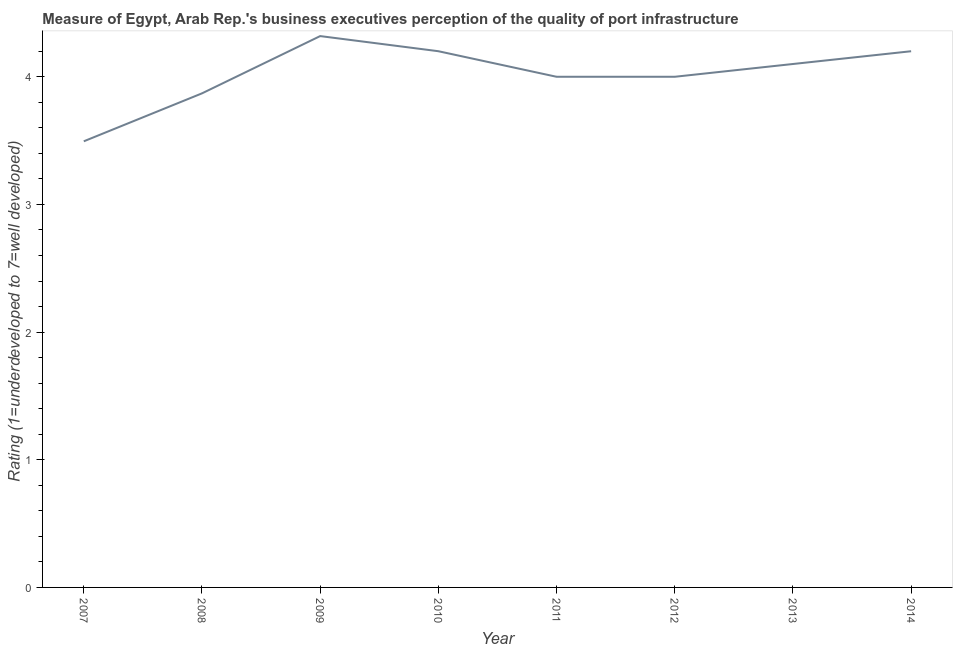What is the rating measuring quality of port infrastructure in 2010?
Offer a terse response. 4.2. Across all years, what is the maximum rating measuring quality of port infrastructure?
Make the answer very short. 4.32. Across all years, what is the minimum rating measuring quality of port infrastructure?
Ensure brevity in your answer.  3.49. In which year was the rating measuring quality of port infrastructure maximum?
Your answer should be very brief. 2009. What is the sum of the rating measuring quality of port infrastructure?
Ensure brevity in your answer.  32.18. What is the difference between the rating measuring quality of port infrastructure in 2009 and 2014?
Your response must be concise. 0.12. What is the average rating measuring quality of port infrastructure per year?
Make the answer very short. 4.02. What is the median rating measuring quality of port infrastructure?
Provide a short and direct response. 4.05. In how many years, is the rating measuring quality of port infrastructure greater than 0.2 ?
Give a very brief answer. 8. Do a majority of the years between 2010 and 2014 (inclusive) have rating measuring quality of port infrastructure greater than 3.8 ?
Offer a very short reply. Yes. What is the ratio of the rating measuring quality of port infrastructure in 2011 to that in 2013?
Provide a short and direct response. 0.98. Is the rating measuring quality of port infrastructure in 2007 less than that in 2014?
Give a very brief answer. Yes. Is the difference between the rating measuring quality of port infrastructure in 2008 and 2013 greater than the difference between any two years?
Provide a short and direct response. No. What is the difference between the highest and the second highest rating measuring quality of port infrastructure?
Offer a terse response. 0.12. Is the sum of the rating measuring quality of port infrastructure in 2013 and 2014 greater than the maximum rating measuring quality of port infrastructure across all years?
Provide a succinct answer. Yes. What is the difference between the highest and the lowest rating measuring quality of port infrastructure?
Provide a short and direct response. 0.82. How many lines are there?
Offer a terse response. 1. How many years are there in the graph?
Offer a very short reply. 8. Are the values on the major ticks of Y-axis written in scientific E-notation?
Your response must be concise. No. What is the title of the graph?
Offer a very short reply. Measure of Egypt, Arab Rep.'s business executives perception of the quality of port infrastructure. What is the label or title of the X-axis?
Provide a short and direct response. Year. What is the label or title of the Y-axis?
Give a very brief answer. Rating (1=underdeveloped to 7=well developed) . What is the Rating (1=underdeveloped to 7=well developed)  in 2007?
Your response must be concise. 3.49. What is the Rating (1=underdeveloped to 7=well developed)  of 2008?
Ensure brevity in your answer.  3.87. What is the Rating (1=underdeveloped to 7=well developed)  in 2009?
Provide a short and direct response. 4.32. What is the Rating (1=underdeveloped to 7=well developed)  in 2010?
Provide a succinct answer. 4.2. What is the Rating (1=underdeveloped to 7=well developed)  of 2011?
Ensure brevity in your answer.  4. What is the Rating (1=underdeveloped to 7=well developed)  in 2012?
Provide a short and direct response. 4. What is the difference between the Rating (1=underdeveloped to 7=well developed)  in 2007 and 2008?
Keep it short and to the point. -0.38. What is the difference between the Rating (1=underdeveloped to 7=well developed)  in 2007 and 2009?
Give a very brief answer. -0.82. What is the difference between the Rating (1=underdeveloped to 7=well developed)  in 2007 and 2010?
Keep it short and to the point. -0.71. What is the difference between the Rating (1=underdeveloped to 7=well developed)  in 2007 and 2011?
Offer a terse response. -0.51. What is the difference between the Rating (1=underdeveloped to 7=well developed)  in 2007 and 2012?
Offer a terse response. -0.51. What is the difference between the Rating (1=underdeveloped to 7=well developed)  in 2007 and 2013?
Your answer should be very brief. -0.61. What is the difference between the Rating (1=underdeveloped to 7=well developed)  in 2007 and 2014?
Offer a terse response. -0.71. What is the difference between the Rating (1=underdeveloped to 7=well developed)  in 2008 and 2009?
Your answer should be very brief. -0.45. What is the difference between the Rating (1=underdeveloped to 7=well developed)  in 2008 and 2010?
Give a very brief answer. -0.33. What is the difference between the Rating (1=underdeveloped to 7=well developed)  in 2008 and 2011?
Ensure brevity in your answer.  -0.13. What is the difference between the Rating (1=underdeveloped to 7=well developed)  in 2008 and 2012?
Keep it short and to the point. -0.13. What is the difference between the Rating (1=underdeveloped to 7=well developed)  in 2008 and 2013?
Provide a succinct answer. -0.23. What is the difference between the Rating (1=underdeveloped to 7=well developed)  in 2008 and 2014?
Your response must be concise. -0.33. What is the difference between the Rating (1=underdeveloped to 7=well developed)  in 2009 and 2010?
Your answer should be compact. 0.12. What is the difference between the Rating (1=underdeveloped to 7=well developed)  in 2009 and 2011?
Keep it short and to the point. 0.32. What is the difference between the Rating (1=underdeveloped to 7=well developed)  in 2009 and 2012?
Provide a short and direct response. 0.32. What is the difference between the Rating (1=underdeveloped to 7=well developed)  in 2009 and 2013?
Give a very brief answer. 0.22. What is the difference between the Rating (1=underdeveloped to 7=well developed)  in 2009 and 2014?
Give a very brief answer. 0.12. What is the difference between the Rating (1=underdeveloped to 7=well developed)  in 2010 and 2011?
Provide a short and direct response. 0.2. What is the difference between the Rating (1=underdeveloped to 7=well developed)  in 2010 and 2012?
Offer a very short reply. 0.2. What is the difference between the Rating (1=underdeveloped to 7=well developed)  in 2010 and 2013?
Your answer should be compact. 0.1. What is the difference between the Rating (1=underdeveloped to 7=well developed)  in 2010 and 2014?
Offer a very short reply. 0. What is the difference between the Rating (1=underdeveloped to 7=well developed)  in 2011 and 2013?
Offer a terse response. -0.1. What is the difference between the Rating (1=underdeveloped to 7=well developed)  in 2011 and 2014?
Offer a terse response. -0.2. What is the difference between the Rating (1=underdeveloped to 7=well developed)  in 2012 and 2013?
Offer a very short reply. -0.1. What is the difference between the Rating (1=underdeveloped to 7=well developed)  in 2012 and 2014?
Offer a very short reply. -0.2. What is the difference between the Rating (1=underdeveloped to 7=well developed)  in 2013 and 2014?
Keep it short and to the point. -0.1. What is the ratio of the Rating (1=underdeveloped to 7=well developed)  in 2007 to that in 2008?
Your response must be concise. 0.9. What is the ratio of the Rating (1=underdeveloped to 7=well developed)  in 2007 to that in 2009?
Offer a terse response. 0.81. What is the ratio of the Rating (1=underdeveloped to 7=well developed)  in 2007 to that in 2010?
Offer a terse response. 0.83. What is the ratio of the Rating (1=underdeveloped to 7=well developed)  in 2007 to that in 2011?
Make the answer very short. 0.87. What is the ratio of the Rating (1=underdeveloped to 7=well developed)  in 2007 to that in 2012?
Offer a terse response. 0.87. What is the ratio of the Rating (1=underdeveloped to 7=well developed)  in 2007 to that in 2013?
Provide a short and direct response. 0.85. What is the ratio of the Rating (1=underdeveloped to 7=well developed)  in 2007 to that in 2014?
Provide a short and direct response. 0.83. What is the ratio of the Rating (1=underdeveloped to 7=well developed)  in 2008 to that in 2009?
Give a very brief answer. 0.9. What is the ratio of the Rating (1=underdeveloped to 7=well developed)  in 2008 to that in 2010?
Your answer should be very brief. 0.92. What is the ratio of the Rating (1=underdeveloped to 7=well developed)  in 2008 to that in 2011?
Your answer should be very brief. 0.97. What is the ratio of the Rating (1=underdeveloped to 7=well developed)  in 2008 to that in 2013?
Your answer should be very brief. 0.94. What is the ratio of the Rating (1=underdeveloped to 7=well developed)  in 2008 to that in 2014?
Give a very brief answer. 0.92. What is the ratio of the Rating (1=underdeveloped to 7=well developed)  in 2009 to that in 2010?
Ensure brevity in your answer.  1.03. What is the ratio of the Rating (1=underdeveloped to 7=well developed)  in 2009 to that in 2011?
Your answer should be compact. 1.08. What is the ratio of the Rating (1=underdeveloped to 7=well developed)  in 2009 to that in 2013?
Your answer should be very brief. 1.05. What is the ratio of the Rating (1=underdeveloped to 7=well developed)  in 2009 to that in 2014?
Keep it short and to the point. 1.03. What is the ratio of the Rating (1=underdeveloped to 7=well developed)  in 2010 to that in 2012?
Make the answer very short. 1.05. What is the ratio of the Rating (1=underdeveloped to 7=well developed)  in 2011 to that in 2012?
Make the answer very short. 1. What is the ratio of the Rating (1=underdeveloped to 7=well developed)  in 2011 to that in 2013?
Ensure brevity in your answer.  0.98. What is the ratio of the Rating (1=underdeveloped to 7=well developed)  in 2011 to that in 2014?
Your response must be concise. 0.95. What is the ratio of the Rating (1=underdeveloped to 7=well developed)  in 2012 to that in 2014?
Ensure brevity in your answer.  0.95. What is the ratio of the Rating (1=underdeveloped to 7=well developed)  in 2013 to that in 2014?
Offer a very short reply. 0.98. 